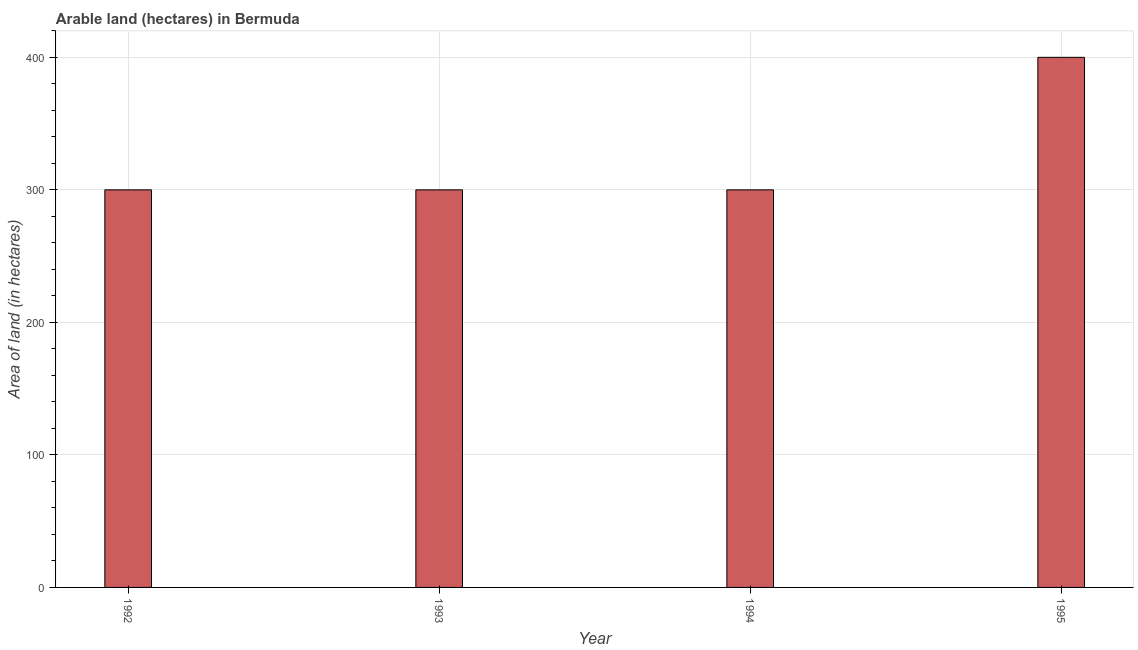Does the graph contain any zero values?
Make the answer very short. No. What is the title of the graph?
Ensure brevity in your answer.  Arable land (hectares) in Bermuda. What is the label or title of the Y-axis?
Provide a succinct answer. Area of land (in hectares). What is the area of land in 1993?
Give a very brief answer. 300. Across all years, what is the minimum area of land?
Ensure brevity in your answer.  300. What is the sum of the area of land?
Your answer should be very brief. 1300. What is the average area of land per year?
Provide a succinct answer. 325. What is the median area of land?
Your response must be concise. 300. Do a majority of the years between 1992 and 1994 (inclusive) have area of land greater than 240 hectares?
Give a very brief answer. Yes. What is the ratio of the area of land in 1994 to that in 1995?
Provide a short and direct response. 0.75. Is the difference between the area of land in 1993 and 1994 greater than the difference between any two years?
Give a very brief answer. No. Are all the bars in the graph horizontal?
Your answer should be very brief. No. What is the Area of land (in hectares) of 1992?
Your answer should be very brief. 300. What is the Area of land (in hectares) of 1993?
Your answer should be very brief. 300. What is the Area of land (in hectares) of 1994?
Provide a succinct answer. 300. What is the difference between the Area of land (in hectares) in 1992 and 1994?
Your response must be concise. 0. What is the difference between the Area of land (in hectares) in 1992 and 1995?
Ensure brevity in your answer.  -100. What is the difference between the Area of land (in hectares) in 1993 and 1994?
Your answer should be compact. 0. What is the difference between the Area of land (in hectares) in 1993 and 1995?
Your response must be concise. -100. What is the difference between the Area of land (in hectares) in 1994 and 1995?
Your answer should be very brief. -100. What is the ratio of the Area of land (in hectares) in 1992 to that in 1994?
Your answer should be very brief. 1. What is the ratio of the Area of land (in hectares) in 1992 to that in 1995?
Keep it short and to the point. 0.75. What is the ratio of the Area of land (in hectares) in 1993 to that in 1995?
Give a very brief answer. 0.75. 